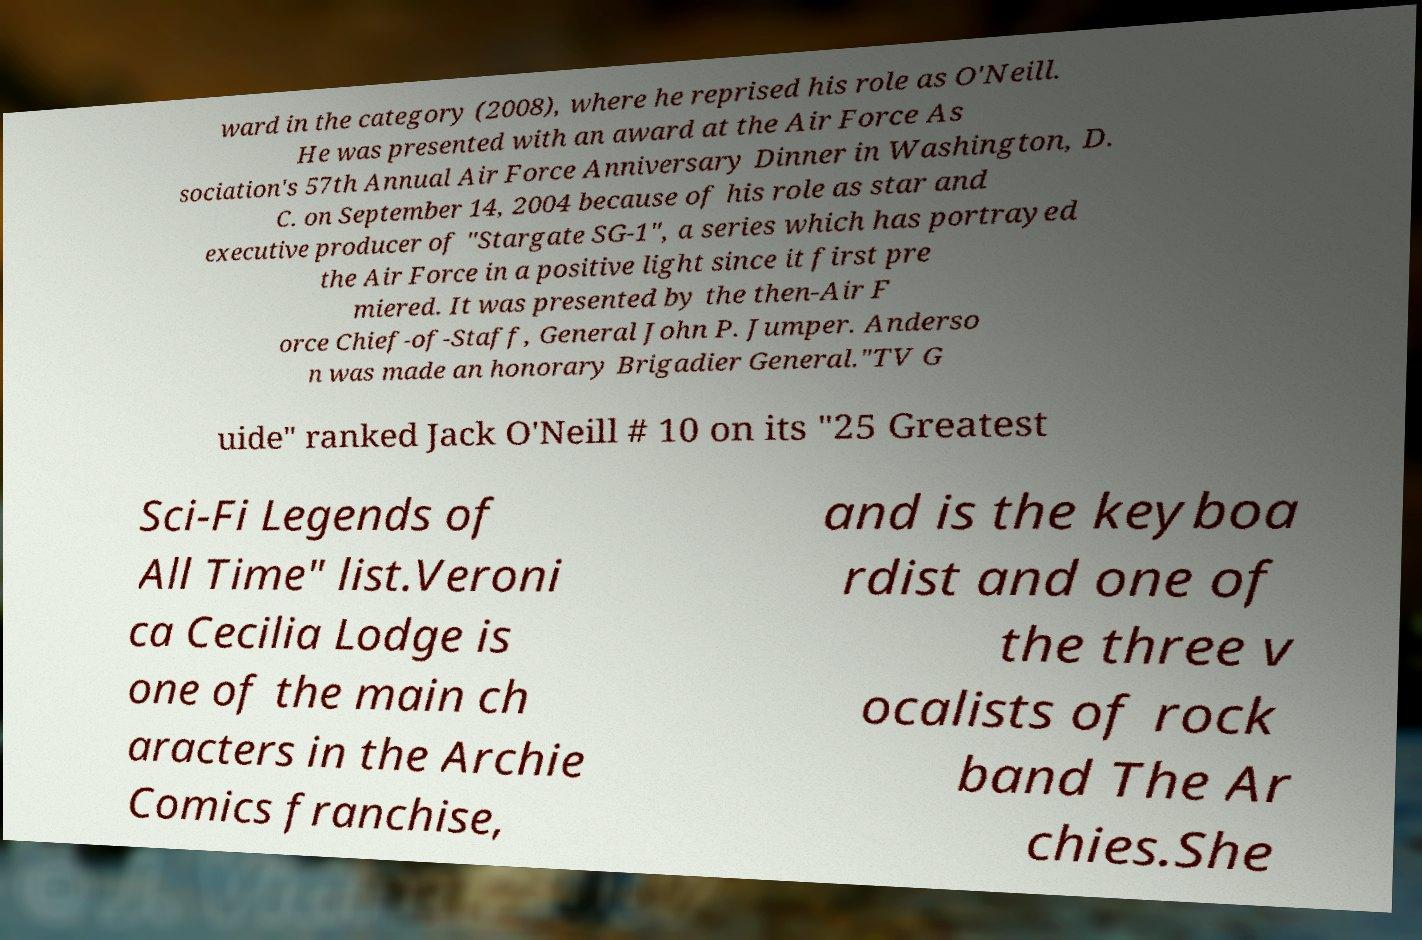Can you accurately transcribe the text from the provided image for me? ward in the category (2008), where he reprised his role as O'Neill. He was presented with an award at the Air Force As sociation's 57th Annual Air Force Anniversary Dinner in Washington, D. C. on September 14, 2004 because of his role as star and executive producer of "Stargate SG-1", a series which has portrayed the Air Force in a positive light since it first pre miered. It was presented by the then-Air F orce Chief-of-Staff, General John P. Jumper. Anderso n was made an honorary Brigadier General."TV G uide" ranked Jack O'Neill # 10 on its "25 Greatest Sci-Fi Legends of All Time" list.Veroni ca Cecilia Lodge is one of the main ch aracters in the Archie Comics franchise, and is the keyboa rdist and one of the three v ocalists of rock band The Ar chies.She 